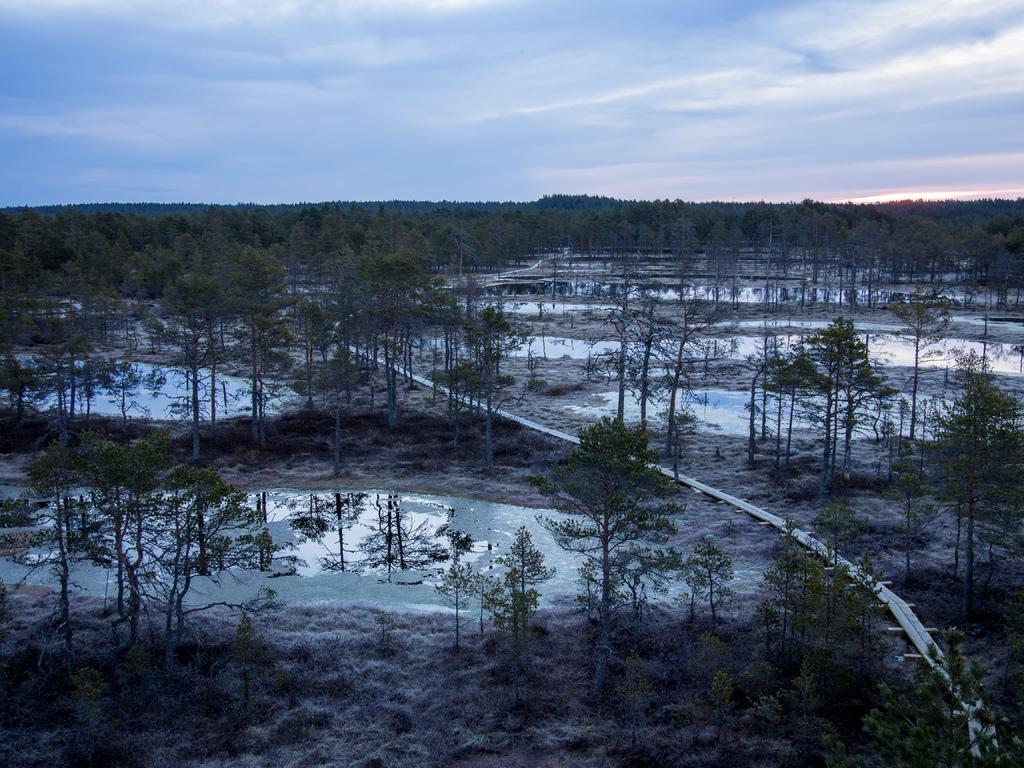Could you give a brief overview of what you see in this image? In this picture we can see there are trees, water and an object. At the top of the image, there is the cloudy sky. 